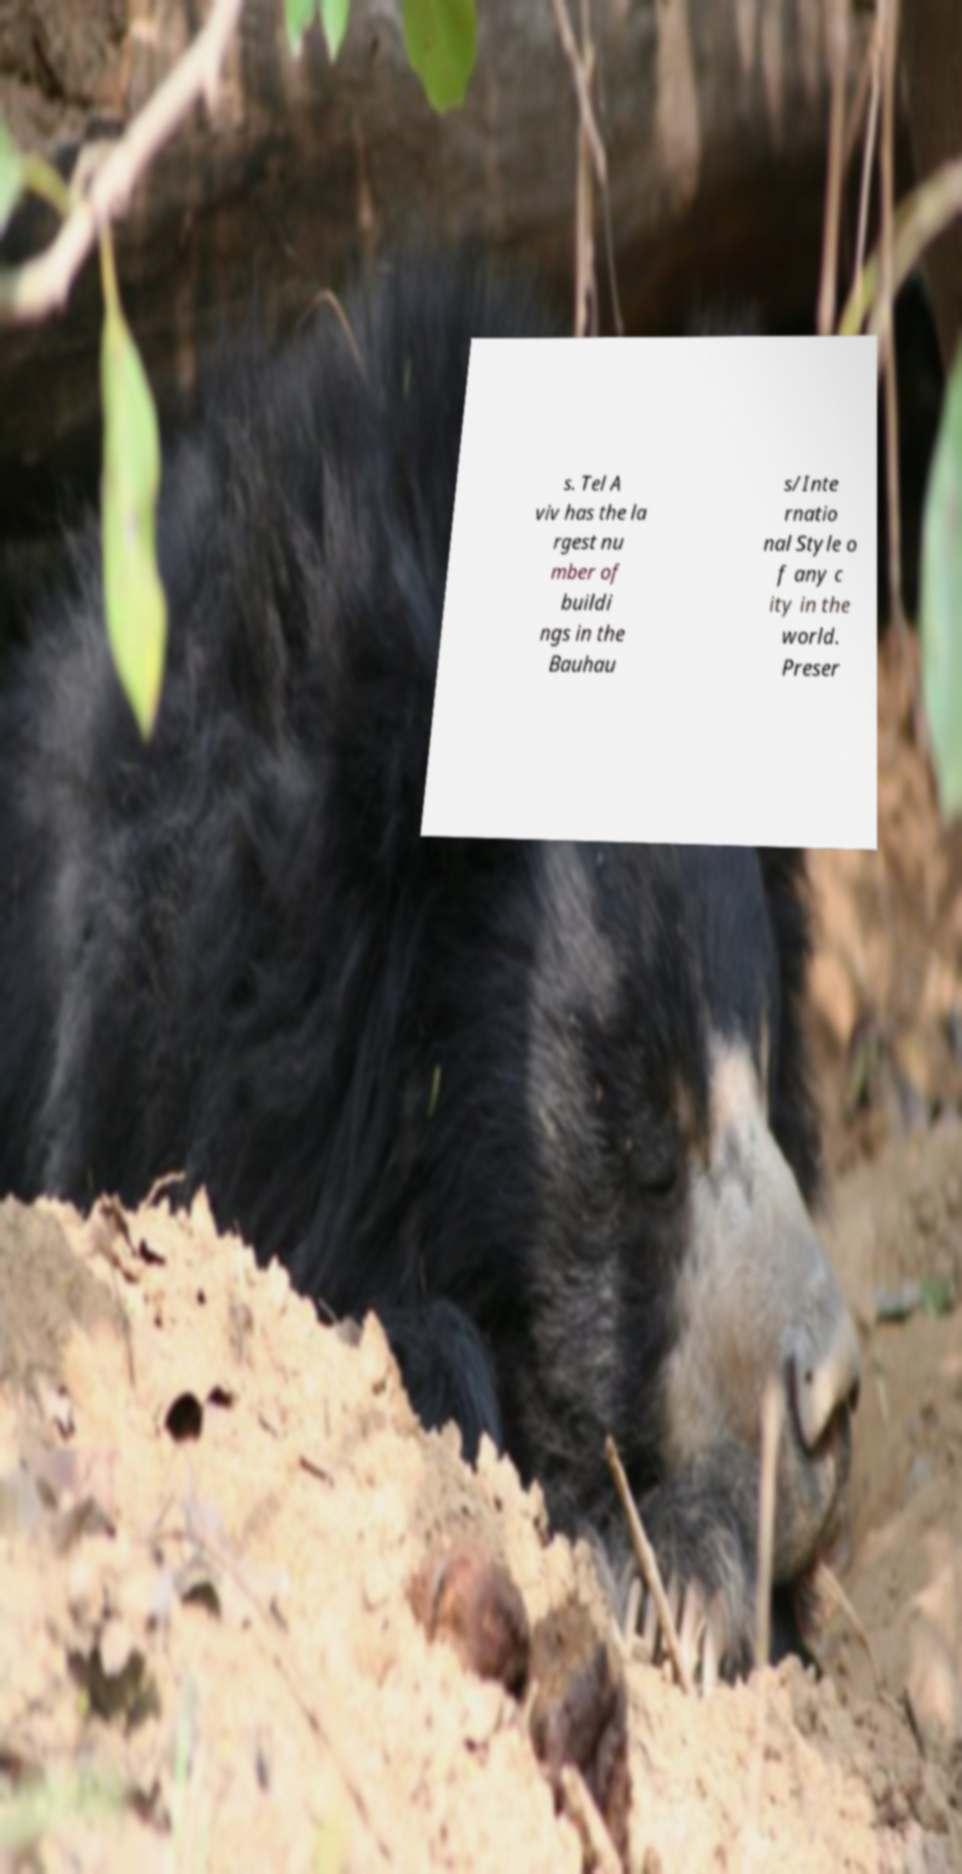Can you accurately transcribe the text from the provided image for me? s. Tel A viv has the la rgest nu mber of buildi ngs in the Bauhau s/Inte rnatio nal Style o f any c ity in the world. Preser 